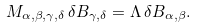Convert formula to latex. <formula><loc_0><loc_0><loc_500><loc_500>M _ { \alpha , \beta , \gamma , \delta } \, \delta B _ { \gamma , \delta } = \Lambda \, \delta B _ { \alpha , \beta } .</formula> 